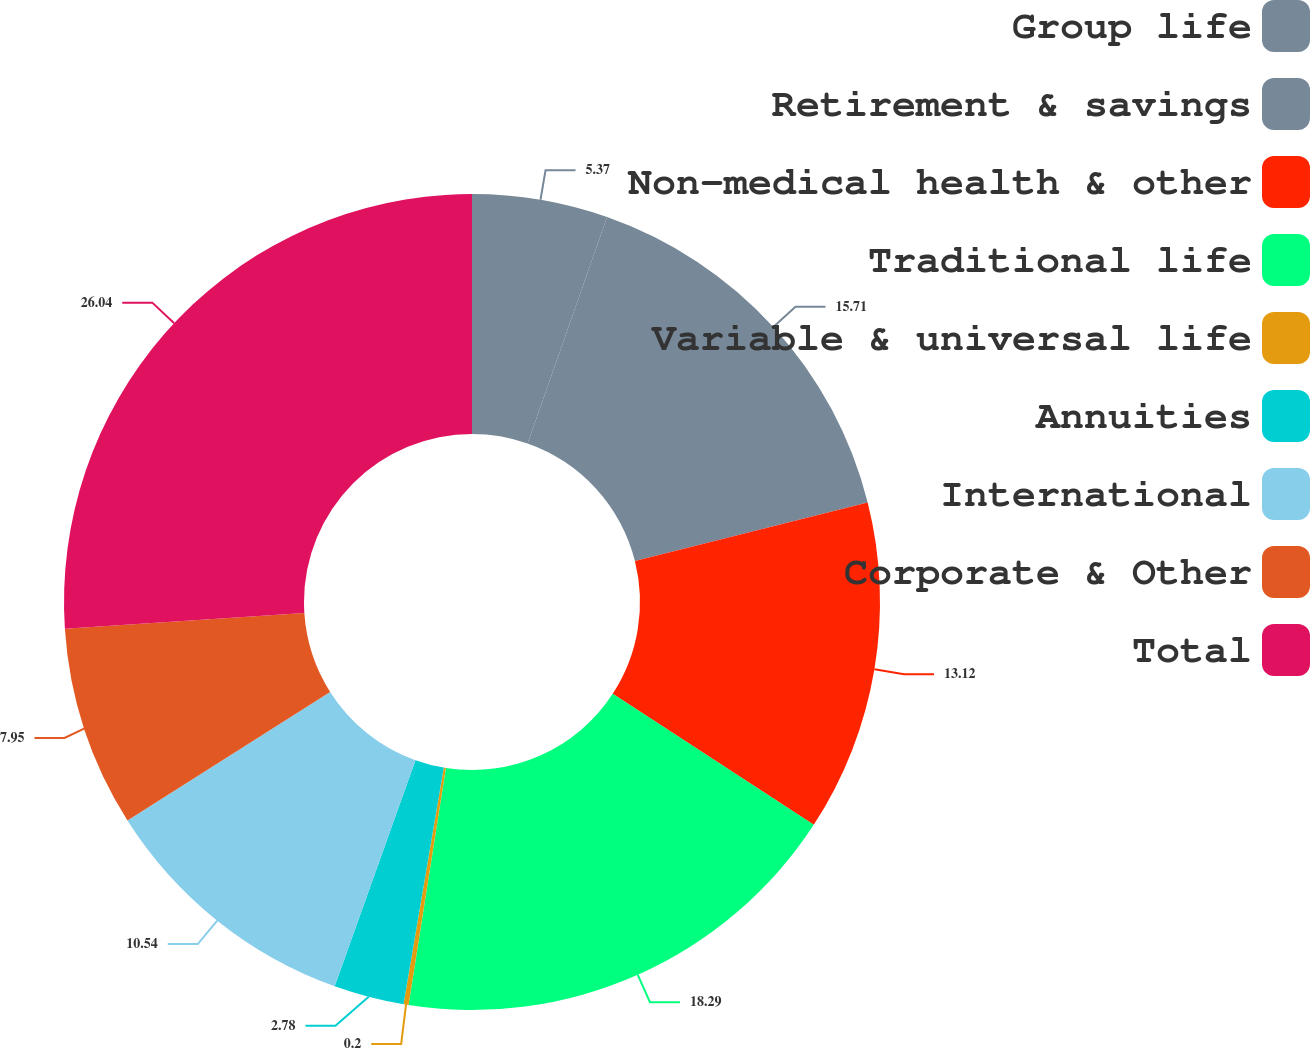Convert chart to OTSL. <chart><loc_0><loc_0><loc_500><loc_500><pie_chart><fcel>Group life<fcel>Retirement & savings<fcel>Non-medical health & other<fcel>Traditional life<fcel>Variable & universal life<fcel>Annuities<fcel>International<fcel>Corporate & Other<fcel>Total<nl><fcel>5.37%<fcel>15.71%<fcel>13.12%<fcel>18.29%<fcel>0.2%<fcel>2.78%<fcel>10.54%<fcel>7.95%<fcel>26.05%<nl></chart> 